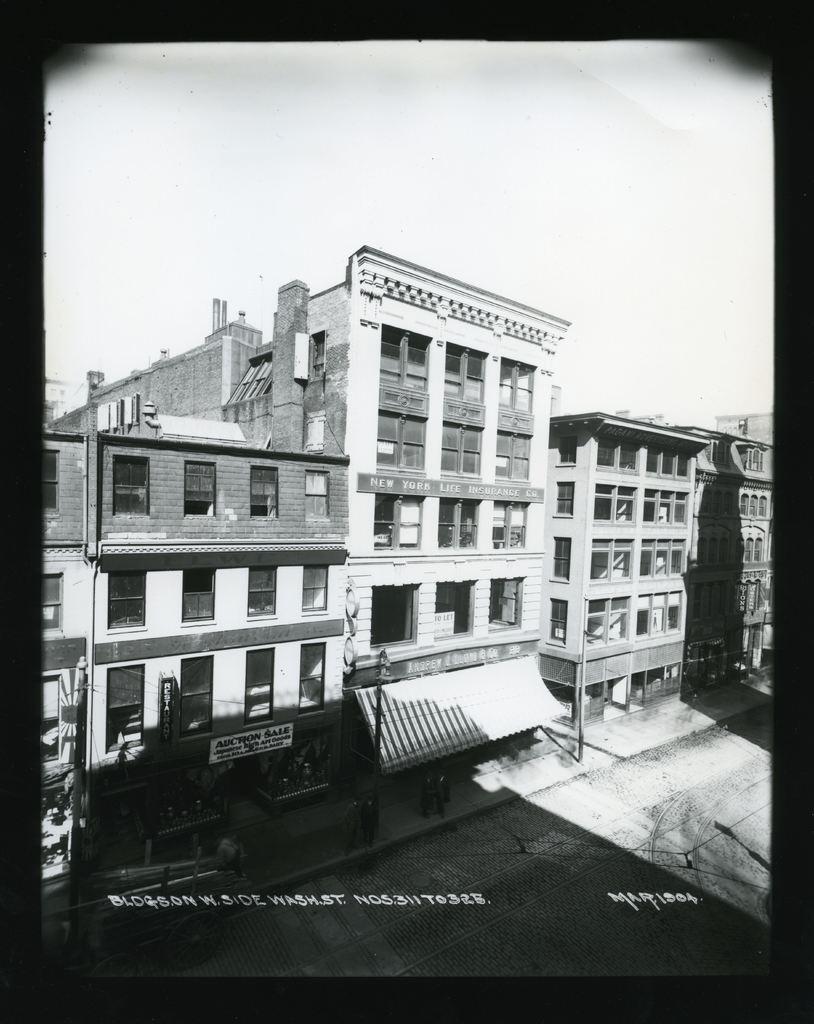Please provide a concise description of this image. This is a black and white image. In the image there are buildings with walls, pillars, glass windows and roofs. And also there are stores with name boards and glass walls. On the footpath there are few people and also there is a pole. And there is some text. 